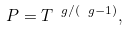Convert formula to latex. <formula><loc_0><loc_0><loc_500><loc_500>P = T ^ { \ g / ( \ g - 1 ) } ,</formula> 